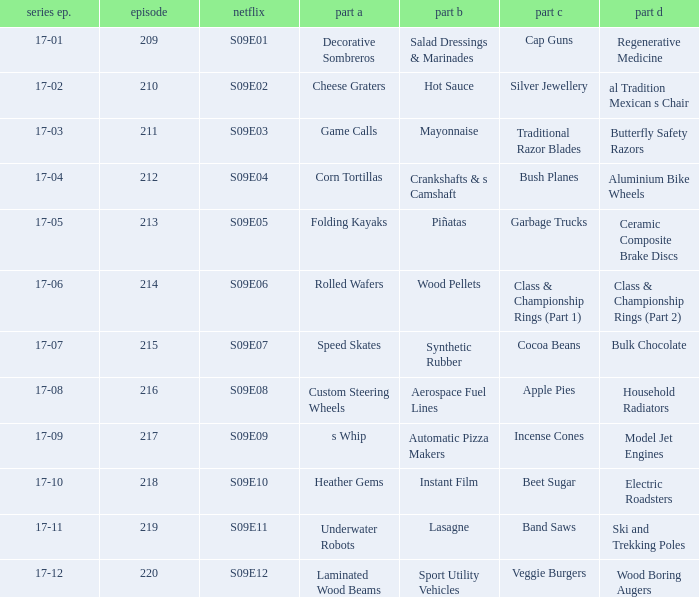How many segments involve wood boring augers Laminated Wood Beams. 